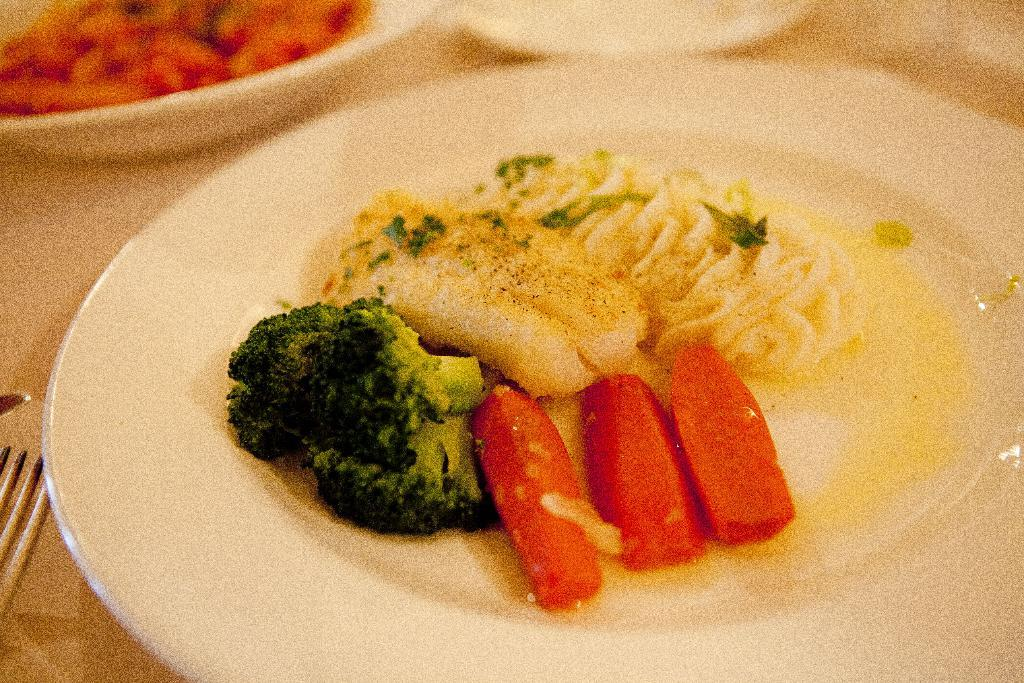What type of food is on the plate in the image? The specific type of food on the plate cannot be determined from the provided facts. What type of food is in the bowl in the image? The specific type of food in the bowl cannot be determined from the provided facts. How many plates are visible in the image? There are plates in the image. How many bowls are visible in the image? There is a bowl in the image. What utensil is present on the table in the image? There is a fork on the table in the image. What color is the light emitted by the square in the image? There is no light or square present in the image. 